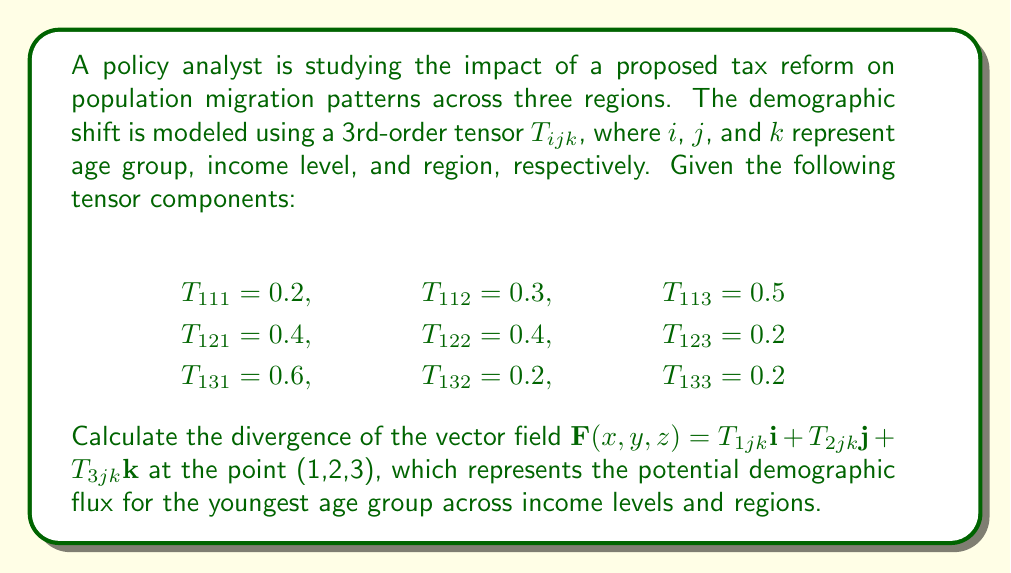Solve this math problem. To solve this problem, we need to follow these steps:

1) The divergence of a vector field $\mathbf{F}(x,y,z) = P\mathbf{i} + Q\mathbf{j} + R\mathbf{k}$ is given by:

   $$\nabla \cdot \mathbf{F} = \frac{\partial P}{\partial x} + \frac{\partial Q}{\partial y} + \frac{\partial R}{\partial z}$$

2) In our case, $P = T_{1jk}$, $Q = T_{2jk}$, and $R = T_{3jk}$

3) We need to evaluate $\frac{\partial T_{1jk}}{\partial x}$, $\frac{\partial T_{2jk}}{\partial y}$, and $\frac{\partial T_{3jk}}{\partial z}$ at the point (1,2,3)

4) For $\frac{\partial T_{1jk}}{\partial x}$:
   At x = 1 (j = 2, k = 3), we have:
   $$\frac{\partial T_{1jk}}{\partial x} = T_{123} - T_{113} = 0.2 - 0.5 = -0.3$$

5) For $\frac{\partial T_{2jk}}{\partial y}$:
   We don't have information about $T_{2jk}$, so this term is 0.

6) For $\frac{\partial T_{3jk}}{\partial z}$:
   We don't have information about $T_{3jk}$, so this term is 0.

7) Adding these terms:

   $$\nabla \cdot \mathbf{F} = -0.3 + 0 + 0 = -0.3$$

Therefore, the divergence of the vector field at the point (1,2,3) is -0.3.
Answer: -0.3 